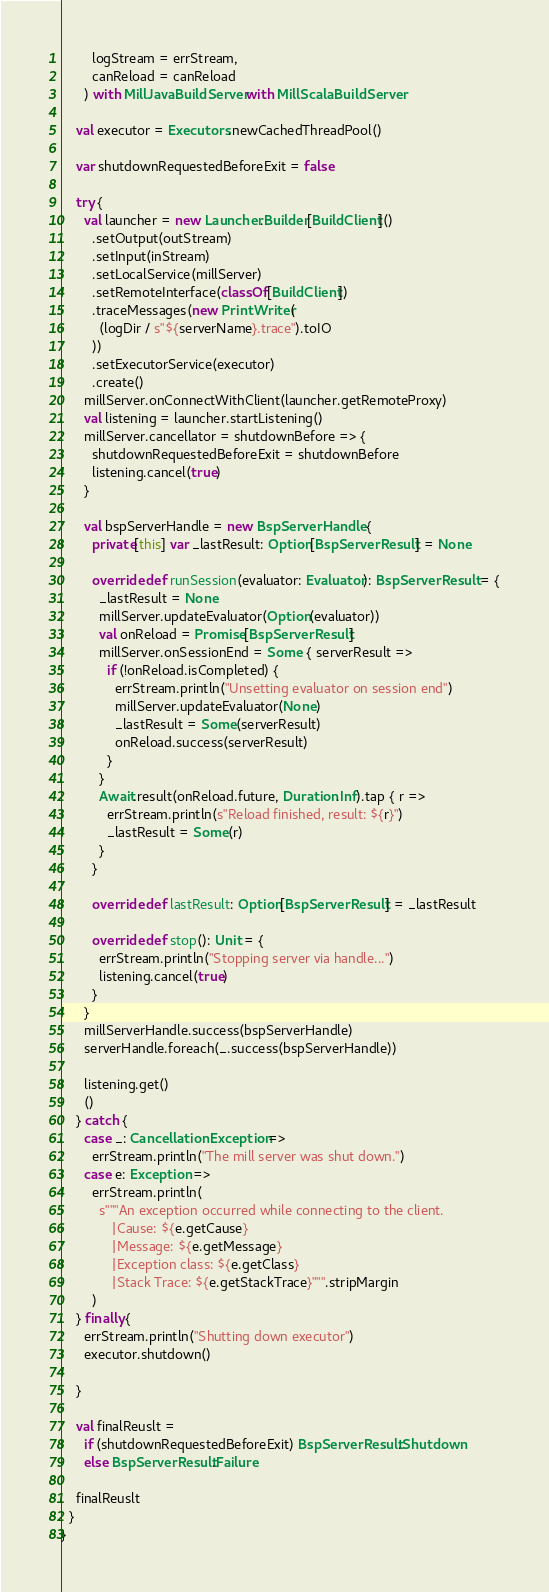Convert code to text. <code><loc_0><loc_0><loc_500><loc_500><_Scala_>        logStream = errStream,
        canReload = canReload
      ) with MillJavaBuildServer with MillScalaBuildServer

    val executor = Executors.newCachedThreadPool()

    var shutdownRequestedBeforeExit = false

    try {
      val launcher = new Launcher.Builder[BuildClient]()
        .setOutput(outStream)
        .setInput(inStream)
        .setLocalService(millServer)
        .setRemoteInterface(classOf[BuildClient])
        .traceMessages(new PrintWriter(
          (logDir / s"${serverName}.trace").toIO
        ))
        .setExecutorService(executor)
        .create()
      millServer.onConnectWithClient(launcher.getRemoteProxy)
      val listening = launcher.startListening()
      millServer.cancellator = shutdownBefore => {
        shutdownRequestedBeforeExit = shutdownBefore
        listening.cancel(true)
      }

      val bspServerHandle = new BspServerHandle {
        private[this] var _lastResult: Option[BspServerResult] = None

        override def runSession(evaluator: Evaluator): BspServerResult = {
          _lastResult = None
          millServer.updateEvaluator(Option(evaluator))
          val onReload = Promise[BspServerResult]
          millServer.onSessionEnd = Some { serverResult =>
            if (!onReload.isCompleted) {
              errStream.println("Unsetting evaluator on session end")
              millServer.updateEvaluator(None)
              _lastResult = Some(serverResult)
              onReload.success(serverResult)
            }
          }
          Await.result(onReload.future, Duration.Inf).tap { r =>
            errStream.println(s"Reload finished, result: ${r}")
            _lastResult = Some(r)
          }
        }

        override def lastResult: Option[BspServerResult] = _lastResult

        override def stop(): Unit = {
          errStream.println("Stopping server via handle...")
          listening.cancel(true)
        }
      }
      millServerHandle.success(bspServerHandle)
      serverHandle.foreach(_.success(bspServerHandle))

      listening.get()
      ()
    } catch {
      case _: CancellationException =>
        errStream.println("The mill server was shut down.")
      case e: Exception =>
        errStream.println(
          s"""An exception occurred while connecting to the client.
             |Cause: ${e.getCause}
             |Message: ${e.getMessage}
             |Exception class: ${e.getClass}
             |Stack Trace: ${e.getStackTrace}""".stripMargin
        )
    } finally {
      errStream.println("Shutting down executor")
      executor.shutdown()

    }

    val finalReuslt =
      if (shutdownRequestedBeforeExit) BspServerResult.Shutdown
      else BspServerResult.Failure

    finalReuslt
  }
}
</code> 